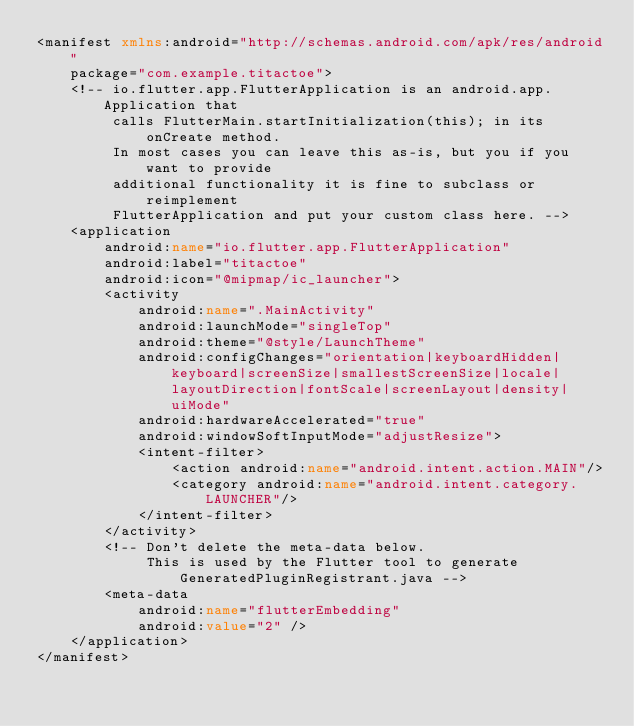<code> <loc_0><loc_0><loc_500><loc_500><_XML_><manifest xmlns:android="http://schemas.android.com/apk/res/android"
    package="com.example.titactoe">
    <!-- io.flutter.app.FlutterApplication is an android.app.Application that
         calls FlutterMain.startInitialization(this); in its onCreate method.
         In most cases you can leave this as-is, but you if you want to provide
         additional functionality it is fine to subclass or reimplement
         FlutterApplication and put your custom class here. -->
    <application
        android:name="io.flutter.app.FlutterApplication"
        android:label="titactoe"
        android:icon="@mipmap/ic_launcher">
        <activity
            android:name=".MainActivity"
            android:launchMode="singleTop"
            android:theme="@style/LaunchTheme"
            android:configChanges="orientation|keyboardHidden|keyboard|screenSize|smallestScreenSize|locale|layoutDirection|fontScale|screenLayout|density|uiMode"
            android:hardwareAccelerated="true"
            android:windowSoftInputMode="adjustResize">
            <intent-filter>
                <action android:name="android.intent.action.MAIN"/>
                <category android:name="android.intent.category.LAUNCHER"/>
            </intent-filter>
        </activity>
        <!-- Don't delete the meta-data below.
             This is used by the Flutter tool to generate GeneratedPluginRegistrant.java -->
        <meta-data
            android:name="flutterEmbedding"
            android:value="2" />
    </application>
</manifest>
</code> 